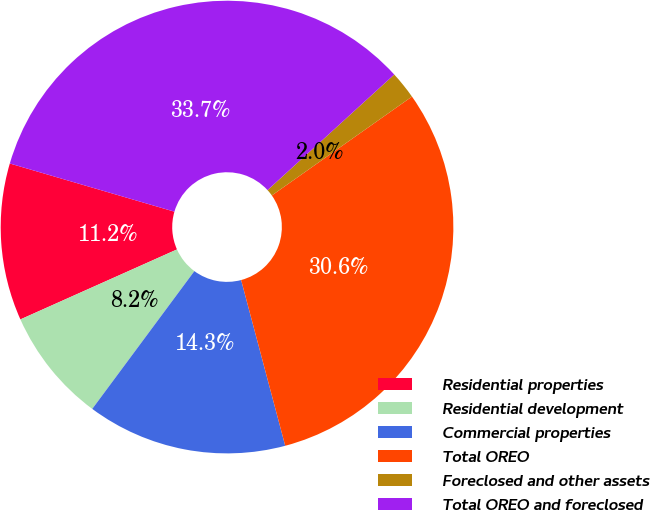<chart> <loc_0><loc_0><loc_500><loc_500><pie_chart><fcel>Residential properties<fcel>Residential development<fcel>Commercial properties<fcel>Total OREO<fcel>Foreclosed and other assets<fcel>Total OREO and foreclosed<nl><fcel>11.22%<fcel>8.16%<fcel>14.29%<fcel>30.64%<fcel>1.99%<fcel>33.7%<nl></chart> 